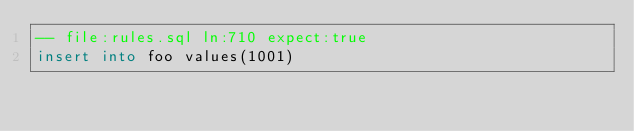Convert code to text. <code><loc_0><loc_0><loc_500><loc_500><_SQL_>-- file:rules.sql ln:710 expect:true
insert into foo values(1001)
</code> 